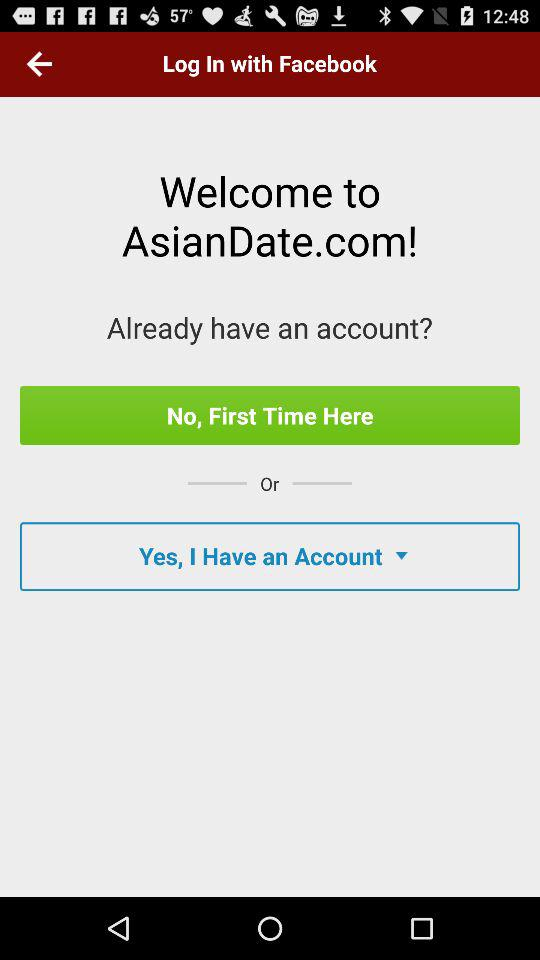What application can we use to log in? You can use "Facebook" to log in. 